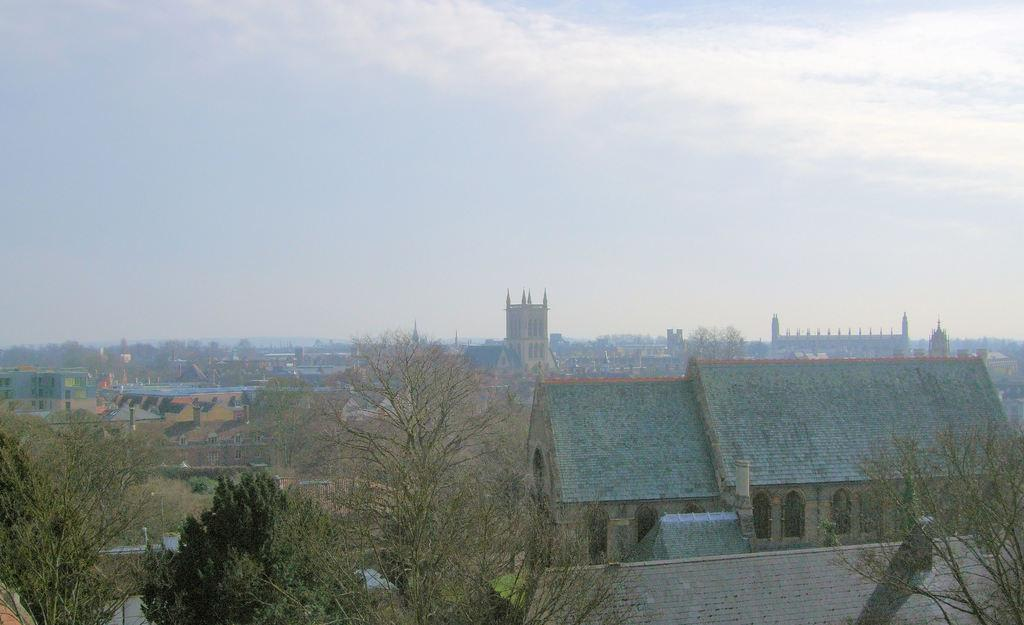What type of natural elements can be seen in the image? There are trees in the image. What type of man-made structures are present in the image? There are buildings in the image. Can you describe the architectural feature of the building on the right side? The building on the right side has arches. What can be seen in the background of the image? There are buildings and the sky visible in the background of the image. How many passengers are visible in the image? There are no passengers present in the image. What type of footwear is the person wearing in the image? There is no person or footwear visible in the image. 